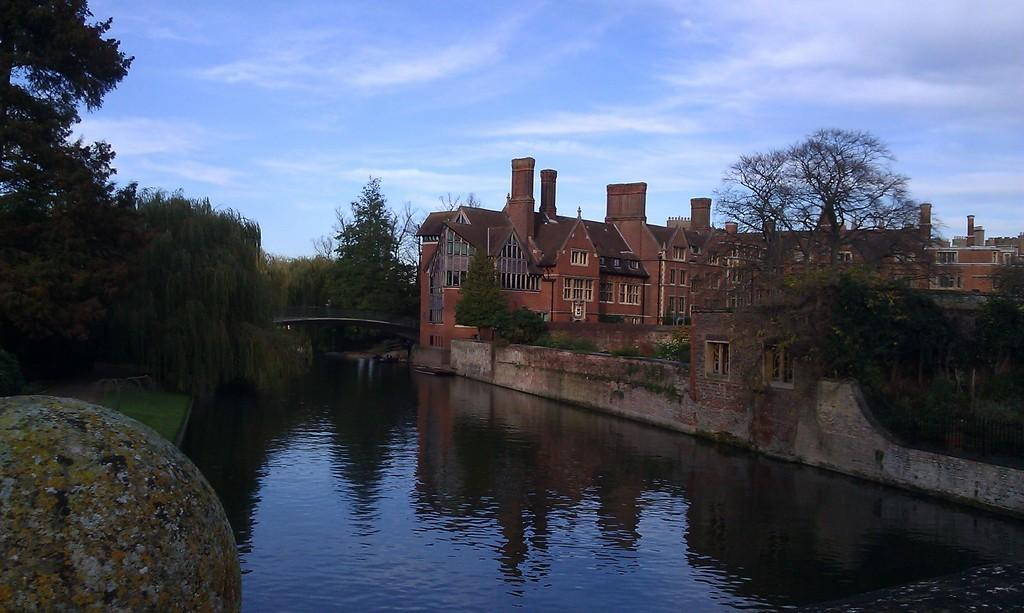What type of natural feature is present in the image? There is a lake in the image. What type of vegetation can be seen in the image? There are trees in the image. What type of man-made structure is present in the image? There is a building in the image. What type of bait is used to catch fish in the lake in the image? There is no mention of fishing or bait in the image, so we cannot determine what type of bait might be used. What type of powder is present in the image? There is no mention of powder in the image, so we cannot determine if any powder is present. 